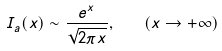<formula> <loc_0><loc_0><loc_500><loc_500>I _ { a } ( x ) \sim \frac { e ^ { x } } { \sqrt { 2 \pi x } } , \quad ( x \rightarrow + \infty )</formula> 